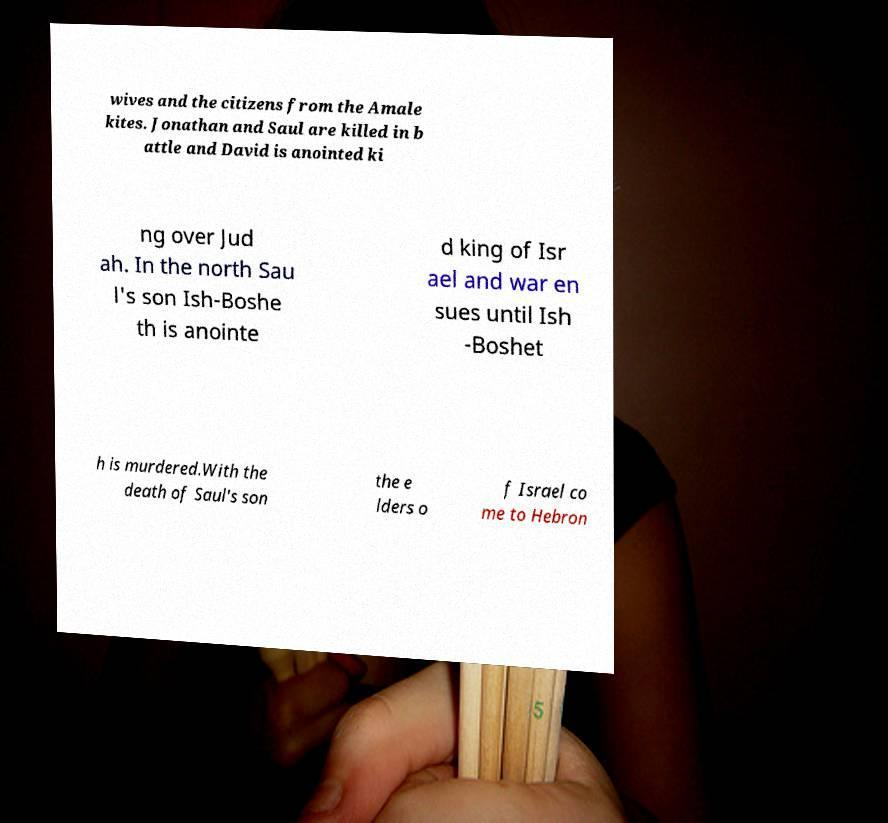For documentation purposes, I need the text within this image transcribed. Could you provide that? wives and the citizens from the Amale kites. Jonathan and Saul are killed in b attle and David is anointed ki ng over Jud ah. In the north Sau l's son Ish-Boshe th is anointe d king of Isr ael and war en sues until Ish -Boshet h is murdered.With the death of Saul's son the e lders o f Israel co me to Hebron 